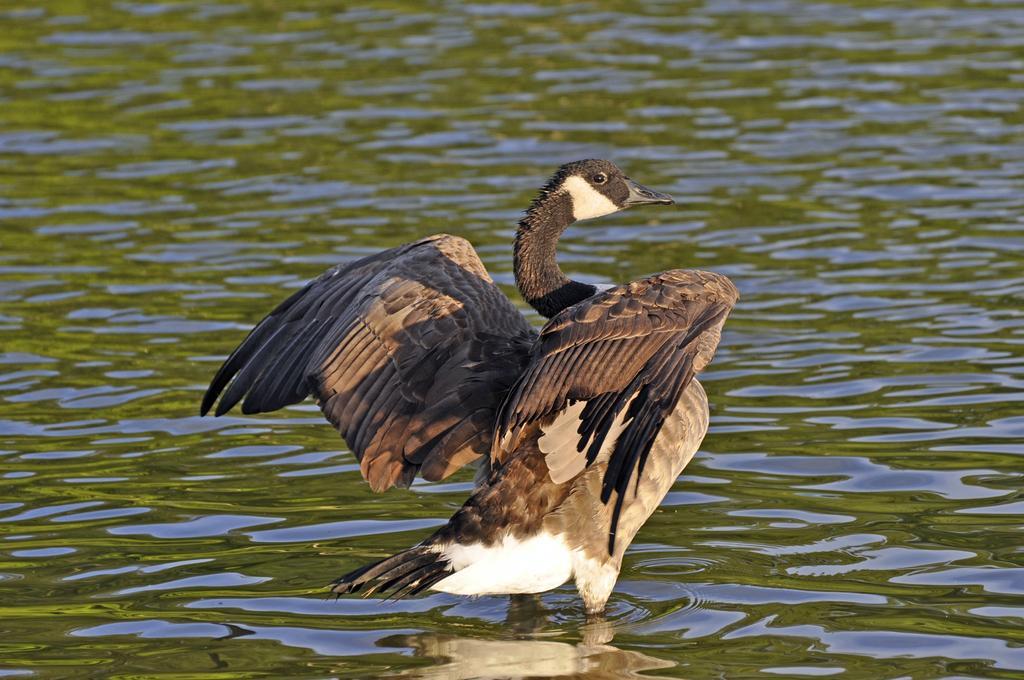How would you summarize this image in a sentence or two? In this image we can see a bird in a large water body. 